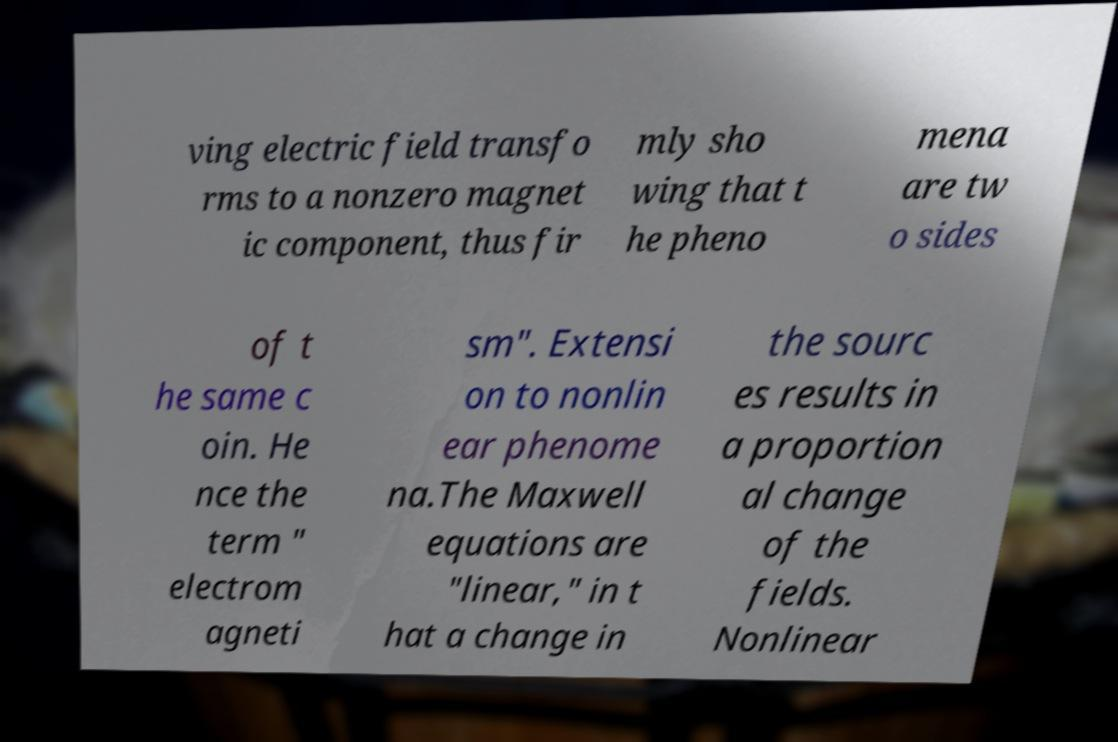Could you extract and type out the text from this image? ving electric field transfo rms to a nonzero magnet ic component, thus fir mly sho wing that t he pheno mena are tw o sides of t he same c oin. He nce the term " electrom agneti sm". Extensi on to nonlin ear phenome na.The Maxwell equations are "linear," in t hat a change in the sourc es results in a proportion al change of the fields. Nonlinear 